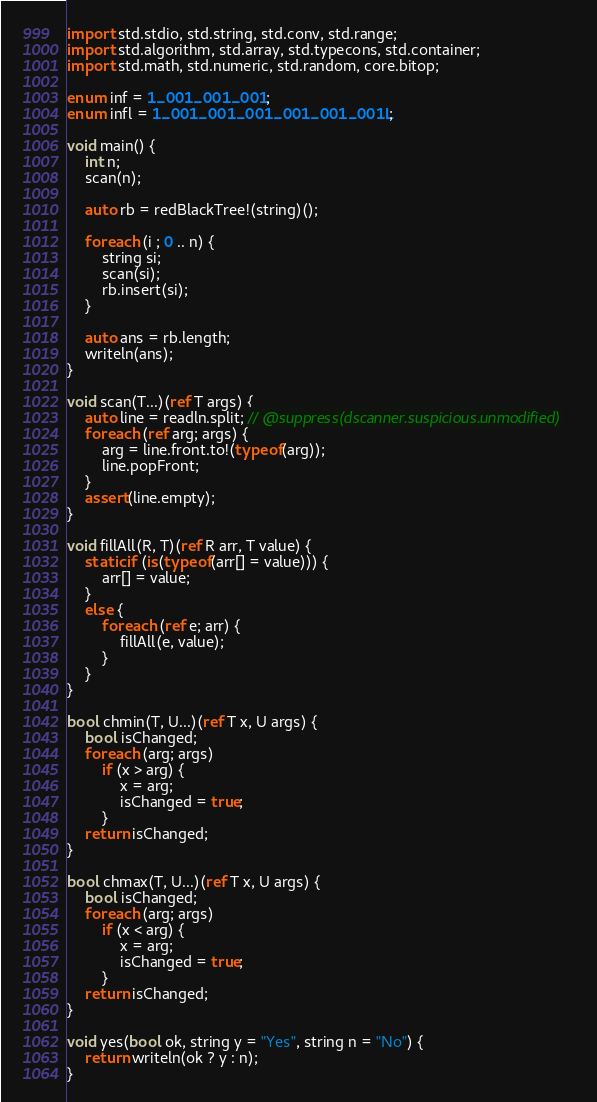<code> <loc_0><loc_0><loc_500><loc_500><_D_>import std.stdio, std.string, std.conv, std.range;
import std.algorithm, std.array, std.typecons, std.container;
import std.math, std.numeric, std.random, core.bitop;

enum inf = 1_001_001_001;
enum infl = 1_001_001_001_001_001_001L;

void main() {
    int n;
    scan(n);

    auto rb = redBlackTree!(string)();

    foreach (i ; 0 .. n) {
        string si;
        scan(si);
        rb.insert(si);
    }

    auto ans = rb.length;
    writeln(ans);
}

void scan(T...)(ref T args) {
    auto line = readln.split; // @suppress(dscanner.suspicious.unmodified)
    foreach (ref arg; args) {
        arg = line.front.to!(typeof(arg));
        line.popFront;
    }
    assert(line.empty);
}

void fillAll(R, T)(ref R arr, T value) {
    static if (is(typeof(arr[] = value))) {
        arr[] = value;
    }
    else {
        foreach (ref e; arr) {
            fillAll(e, value);
        }
    }
}

bool chmin(T, U...)(ref T x, U args) {
    bool isChanged;
    foreach (arg; args)
        if (x > arg) {
            x = arg;
            isChanged = true;
        }
    return isChanged;
}

bool chmax(T, U...)(ref T x, U args) {
    bool isChanged;
    foreach (arg; args)
        if (x < arg) {
            x = arg;
            isChanged = true;
        }
    return isChanged;
}

void yes(bool ok, string y = "Yes", string n = "No") {
    return writeln(ok ? y : n);
}
</code> 